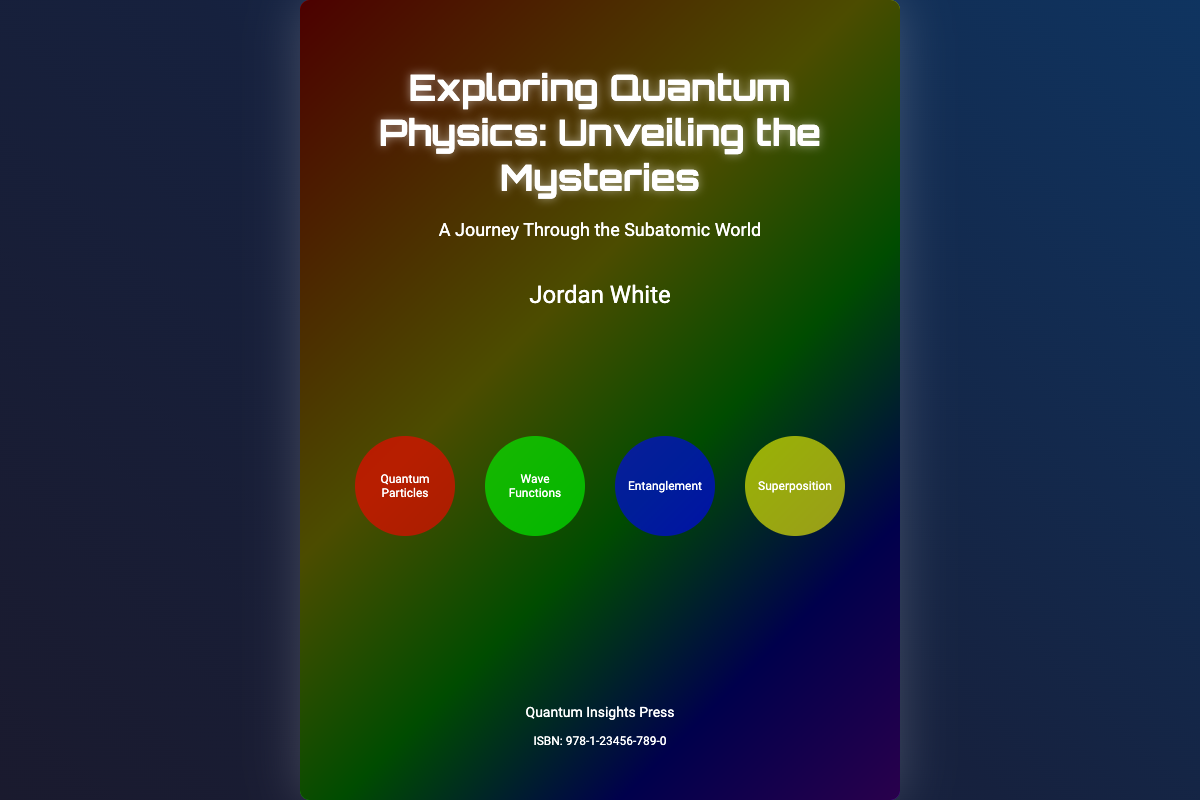What is the title of the book? The title of the book is explicitly stated on the cover as "Exploring Quantum Physics: Unveiling the Mysteries."
Answer: Exploring Quantum Physics: Unveiling the Mysteries Who is the author of the book? The author of the book is listed on the cover as Jordan White.
Answer: Jordan White What is the subtitle of the book? The subtitle is mentioned below the title and reads "A Journey Through the Subatomic World."
Answer: A Journey Through the Subatomic World What publisher released the book? The publisher's name is indicated at the bottom of the cover as "Quantum Insights Press."
Answer: Quantum Insights Press What visual elements represent quantum concepts on the cover? The cover features visual elements labeled "Quantum Particles," "Wave Functions," "Entanglement," and "Superposition."
Answer: Quantum Particles, Wave Functions, Entanglement, Superposition What is the ISBN number for the book? The ISBN number is referenced on the cover as 978-1-23456-789-0.
Answer: 978-1-23456-789-0 What colors are used in the background gradient? The background gradient consists of deep shades of blue, purple, and black, contributing to a cosmic theme.
Answer: Blue, Purple, Black What is the primary theme illustrated by the rainbow gradient? The rainbow gradient symbolizes inclusivity and diversity, aligning with broader social themes.
Answer: Inclusivity 